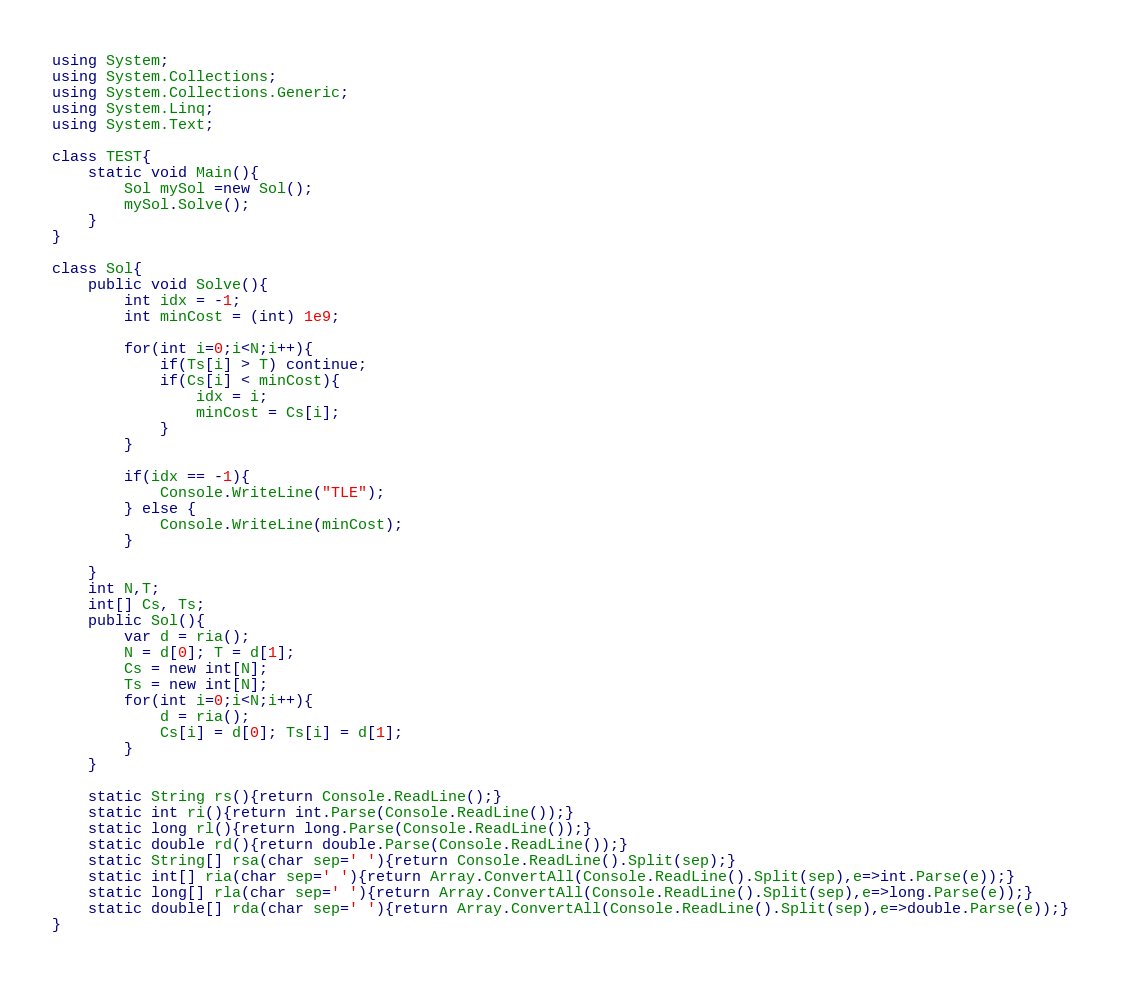Convert code to text. <code><loc_0><loc_0><loc_500><loc_500><_C#_>using System;
using System.Collections;
using System.Collections.Generic;
using System.Linq;
using System.Text;

class TEST{
	static void Main(){
		Sol mySol =new Sol();
		mySol.Solve();
	}
}

class Sol{
	public void Solve(){
		int idx = -1;
		int minCost = (int) 1e9;
		
		for(int i=0;i<N;i++){
			if(Ts[i] > T) continue;
			if(Cs[i] < minCost){
				idx = i;
				minCost = Cs[i];
			}
		}
		
		if(idx == -1){
			Console.WriteLine("TLE");
		} else {
			Console.WriteLine(minCost);
		}
		
	}
	int N,T;
	int[] Cs, Ts;
	public Sol(){
		var d = ria();
		N = d[0]; T = d[1];
		Cs = new int[N];
		Ts = new int[N];
		for(int i=0;i<N;i++){
			d = ria();
			Cs[i] = d[0]; Ts[i] = d[1];
		}
	}

	static String rs(){return Console.ReadLine();}
	static int ri(){return int.Parse(Console.ReadLine());}
	static long rl(){return long.Parse(Console.ReadLine());}
	static double rd(){return double.Parse(Console.ReadLine());}
	static String[] rsa(char sep=' '){return Console.ReadLine().Split(sep);}
	static int[] ria(char sep=' '){return Array.ConvertAll(Console.ReadLine().Split(sep),e=>int.Parse(e));}
	static long[] rla(char sep=' '){return Array.ConvertAll(Console.ReadLine().Split(sep),e=>long.Parse(e));}
	static double[] rda(char sep=' '){return Array.ConvertAll(Console.ReadLine().Split(sep),e=>double.Parse(e));}
}
</code> 